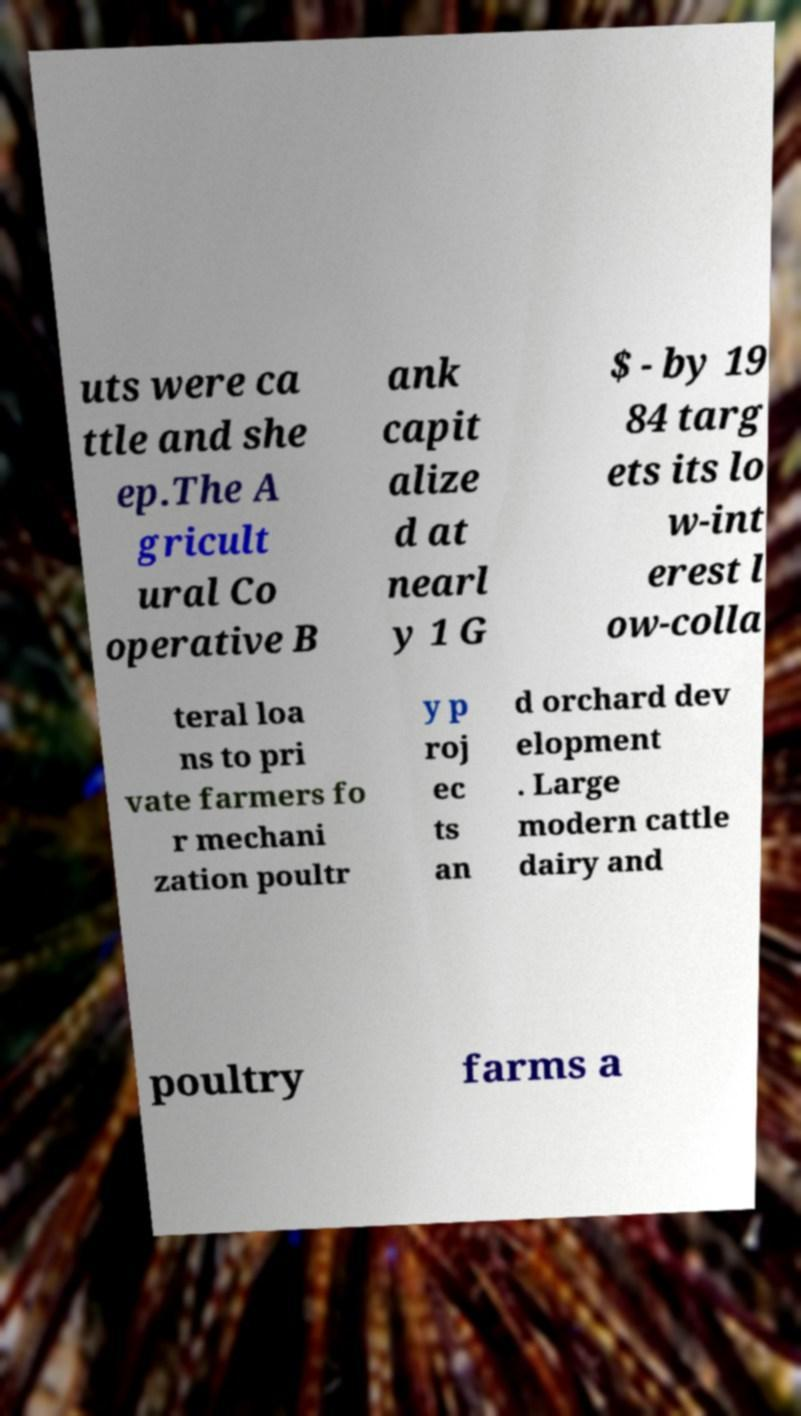For documentation purposes, I need the text within this image transcribed. Could you provide that? uts were ca ttle and she ep.The A gricult ural Co operative B ank capit alize d at nearl y 1 G $ - by 19 84 targ ets its lo w-int erest l ow-colla teral loa ns to pri vate farmers fo r mechani zation poultr y p roj ec ts an d orchard dev elopment . Large modern cattle dairy and poultry farms a 